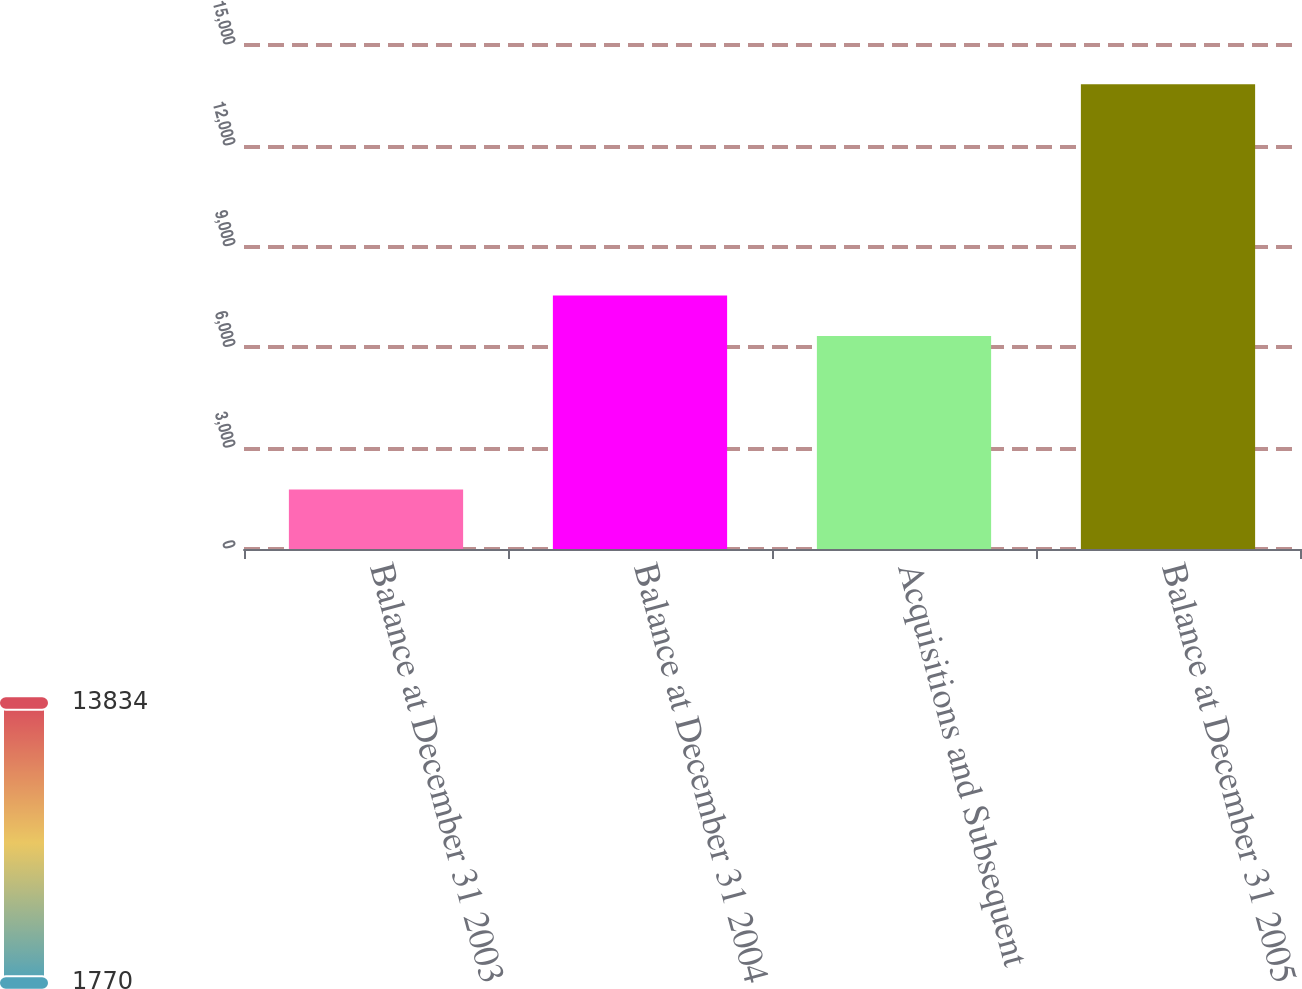Convert chart to OTSL. <chart><loc_0><loc_0><loc_500><loc_500><bar_chart><fcel>Balance at December 31 2003<fcel>Balance at December 31 2004<fcel>Acquisitions and Subsequent<fcel>Balance at December 31 2005<nl><fcel>1770<fcel>7546.4<fcel>6340<fcel>13834<nl></chart> 